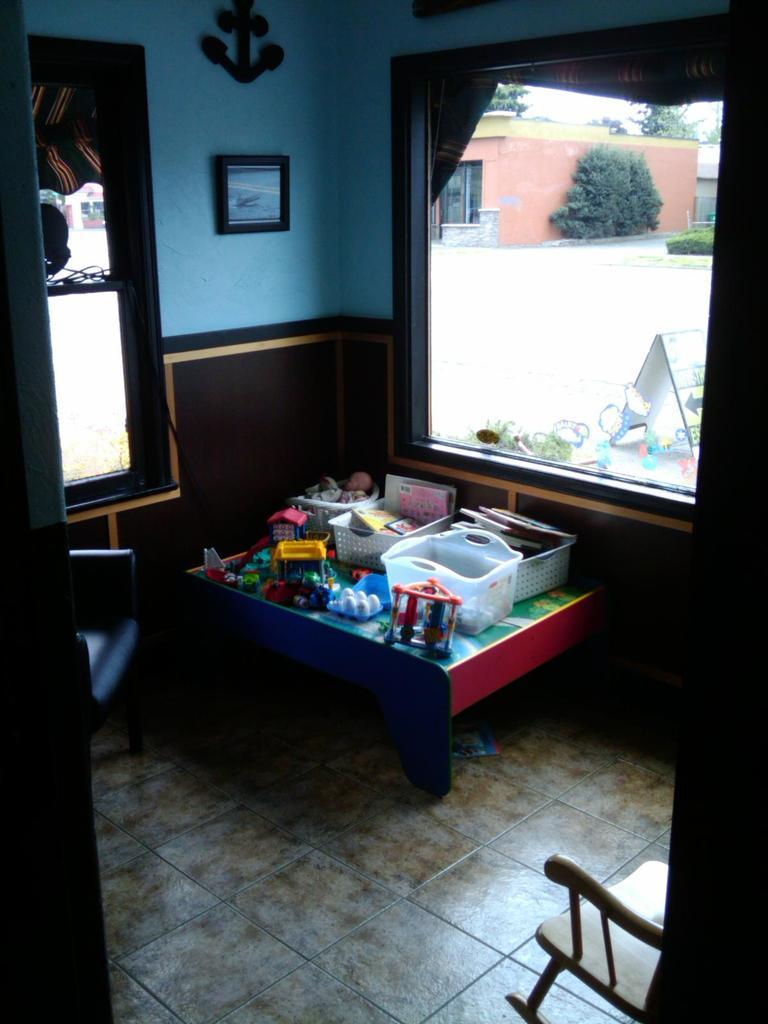What piece of furniture is in the image? There is a table in the image. What is on top of the table? A basket is present on the table, along with other objects. What can be seen on the wall in the image? There is a photo on a wall in the image. Is there any source of natural light in the image? Yes, there is a window in the image. What is on the floor in the image? A chair is on the floor in the image. How many credits are visible on the table in the image? There are no credits present in the image; it features a table with a basket and other objects. What type of spiders can be seen crawling on the chair in the image? There are no spiders present in the image; it features a chair on the floor with no visible spiders. 